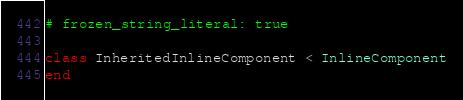<code> <loc_0><loc_0><loc_500><loc_500><_Ruby_># frozen_string_literal: true

class InheritedInlineComponent < InlineComponent
end
</code> 